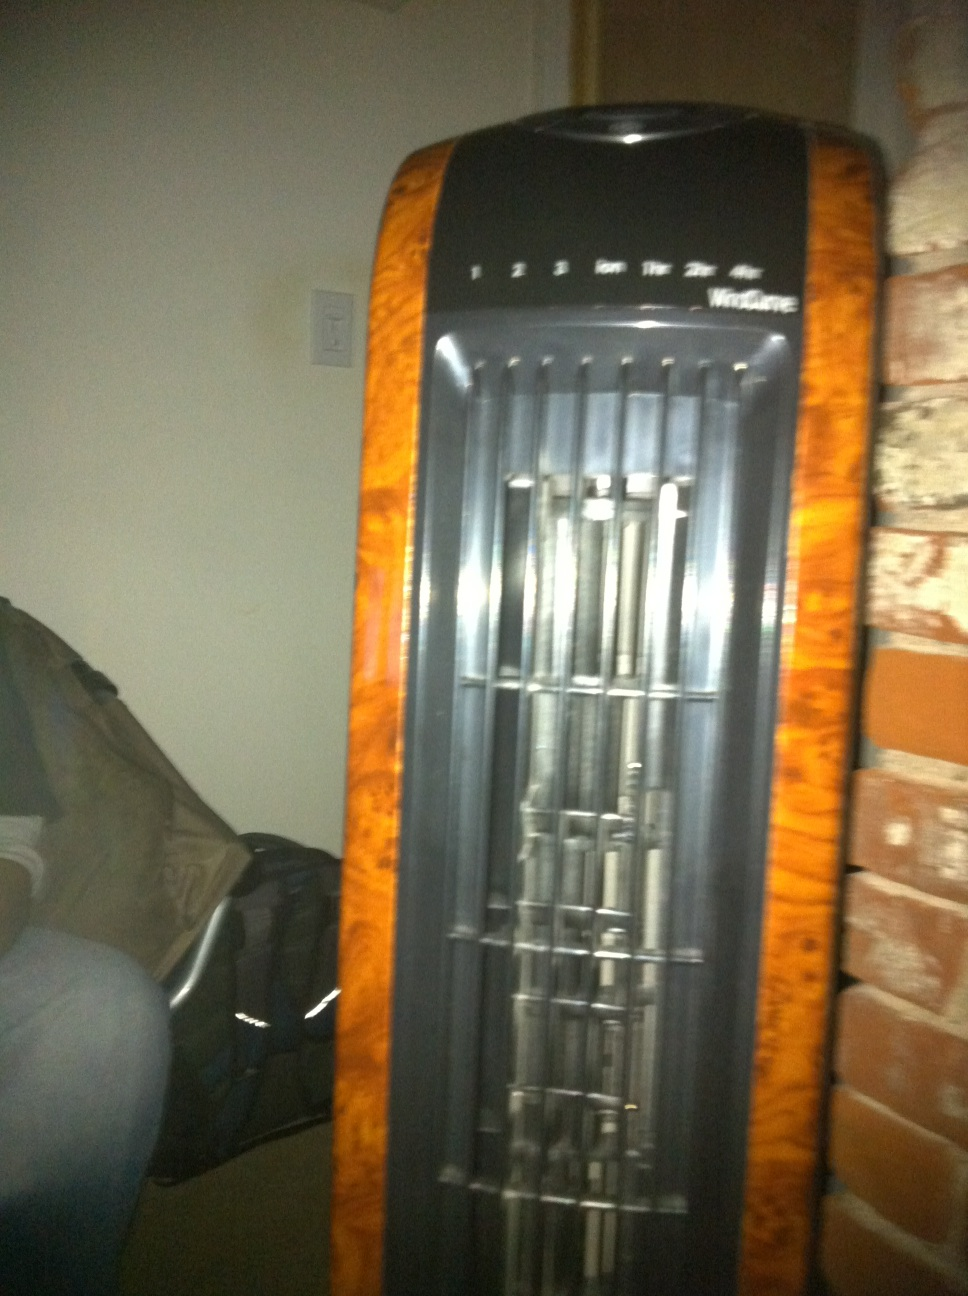My fan. The image shows a tall tower fan with multiple speed settings. It appears to be placed near a wall, possibly in a living room or bedroom, providing cooling comfort to the surrounding area. 